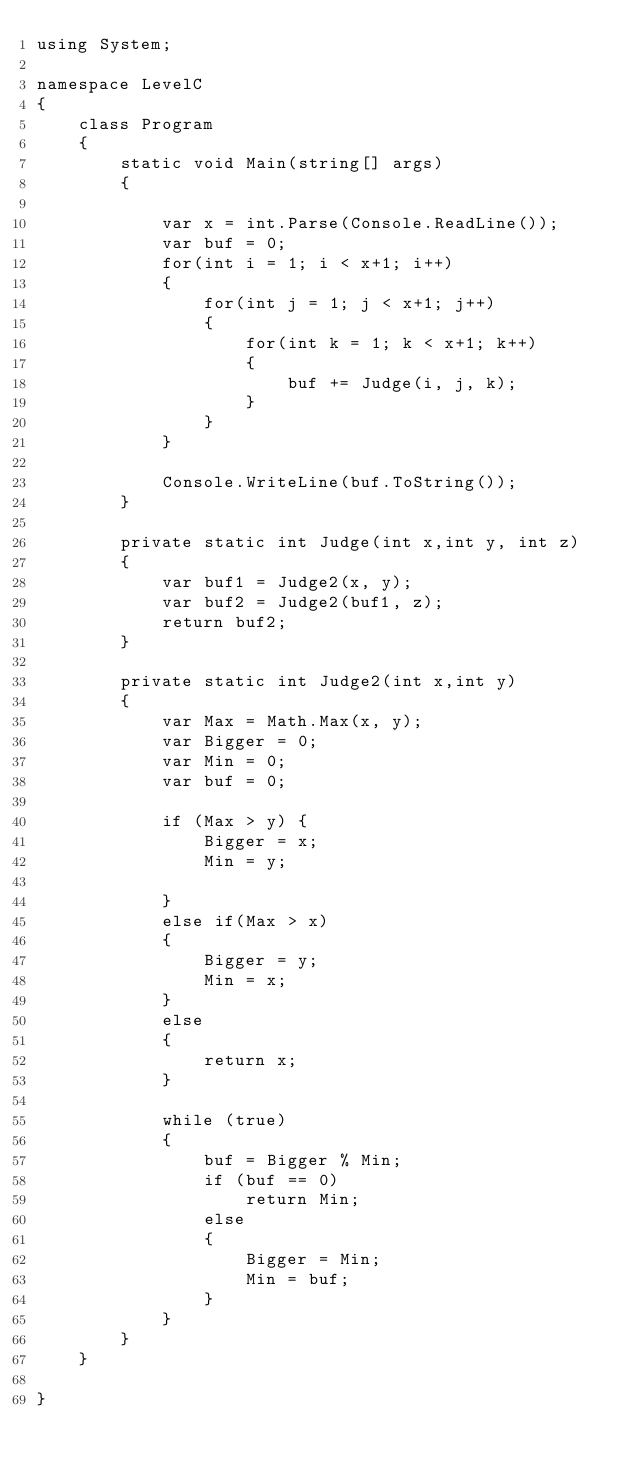<code> <loc_0><loc_0><loc_500><loc_500><_C#_>using System;

namespace LevelC
{
    class Program
    {
        static void Main(string[] args)
        {

            var x = int.Parse(Console.ReadLine());
            var buf = 0;
            for(int i = 1; i < x+1; i++)
            {
                for(int j = 1; j < x+1; j++)
                {
                    for(int k = 1; k < x+1; k++)
                    {
                        buf += Judge(i, j, k);
                    }
                }
            }

            Console.WriteLine(buf.ToString());
        }

        private static int Judge(int x,int y, int z)
        {
            var buf1 = Judge2(x, y);
            var buf2 = Judge2(buf1, z);
            return buf2;
        }

        private static int Judge2(int x,int y)
        {
            var Max = Math.Max(x, y);
            var Bigger = 0;
            var Min = 0;
            var buf = 0;

            if (Max > y) {
                Bigger = x;
                Min = y;

            }
            else if(Max > x)
            {
                Bigger = y;
                Min = x;
            }
            else
            {
                return x;
            }

            while (true)
            {
                buf = Bigger % Min;
                if (buf == 0)
                    return Min;
                else
                {
                    Bigger = Min;
                    Min = buf;
                }
            }
        }
    }

}
</code> 